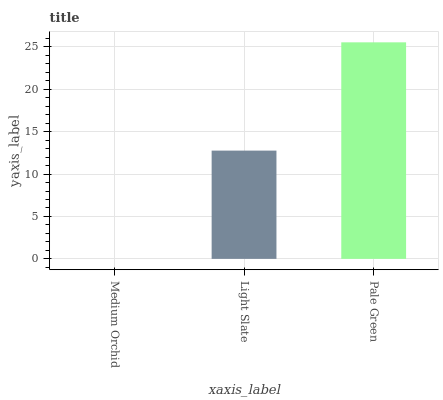Is Medium Orchid the minimum?
Answer yes or no. Yes. Is Pale Green the maximum?
Answer yes or no. Yes. Is Light Slate the minimum?
Answer yes or no. No. Is Light Slate the maximum?
Answer yes or no. No. Is Light Slate greater than Medium Orchid?
Answer yes or no. Yes. Is Medium Orchid less than Light Slate?
Answer yes or no. Yes. Is Medium Orchid greater than Light Slate?
Answer yes or no. No. Is Light Slate less than Medium Orchid?
Answer yes or no. No. Is Light Slate the high median?
Answer yes or no. Yes. Is Light Slate the low median?
Answer yes or no. Yes. Is Medium Orchid the high median?
Answer yes or no. No. Is Pale Green the low median?
Answer yes or no. No. 